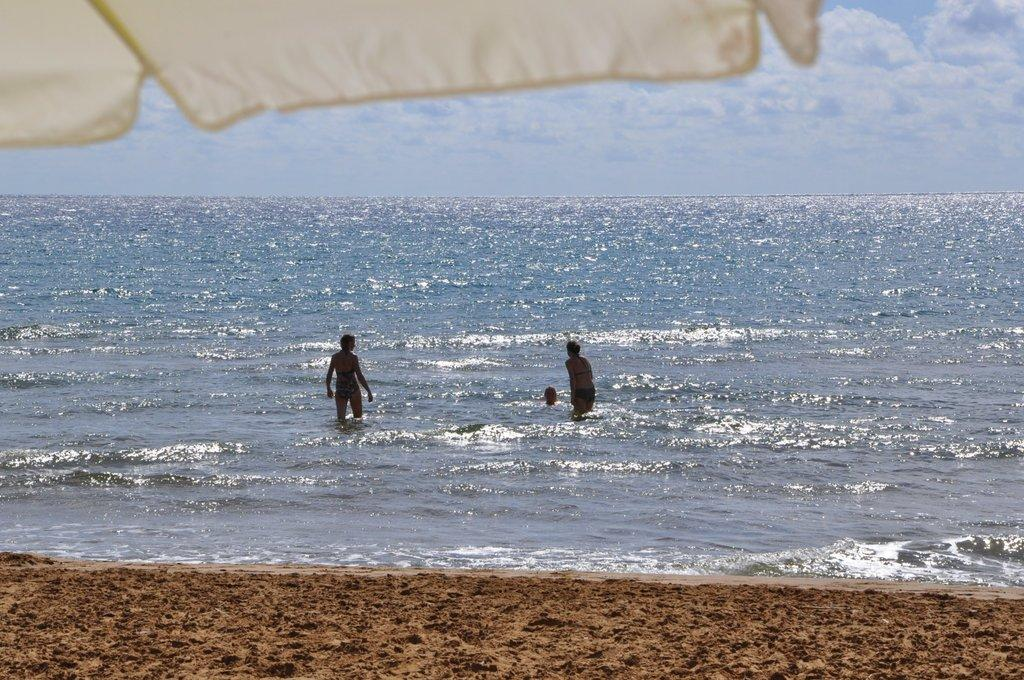What type of terrain is visible in the image? There is sand in the image. What are the three persons doing in the image? The three persons are in the water. Can you describe the object in the left top corner of the image? There is a white color object in the left top corner of the image. What type of hope can be seen growing in the sand in the image? There is no hope visible in the image, as hope is an abstract concept and not a physical object that can be seen. 